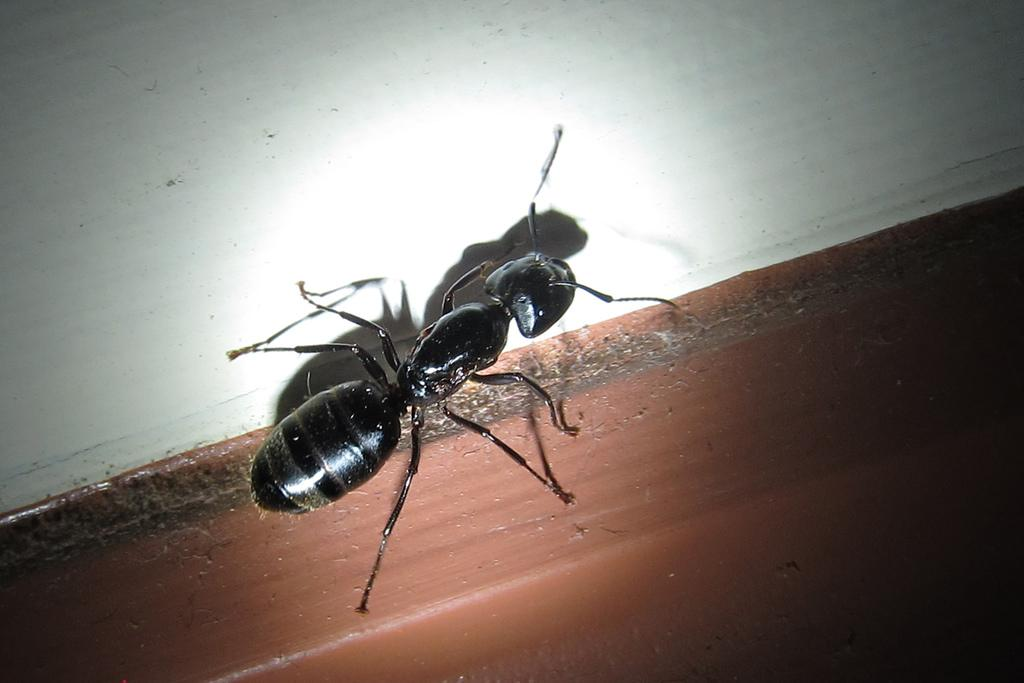What type of creature is in the image? There is an insect in the image. What color is the insect? The insect is black in color. What is the background or surface in the image? The insect is on a white and brown surface. What type of secretary is visible in the image? There is no secretary present in the image; it features an insect on a white and brown surface. What type of class is being conducted in the image? There is no class or educational setting present in the image; it features an insect on a white and brown surface. 